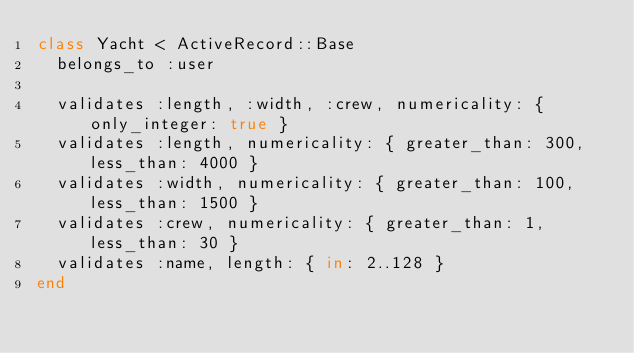<code> <loc_0><loc_0><loc_500><loc_500><_Ruby_>class Yacht < ActiveRecord::Base
  belongs_to :user

  validates :length, :width, :crew, numericality: { only_integer: true }
  validates :length, numericality: { greater_than: 300, less_than: 4000 }
  validates :width, numericality: { greater_than: 100, less_than: 1500 }
  validates :crew, numericality: { greater_than: 1, less_than: 30 }
  validates :name, length: { in: 2..128 }
end
</code> 